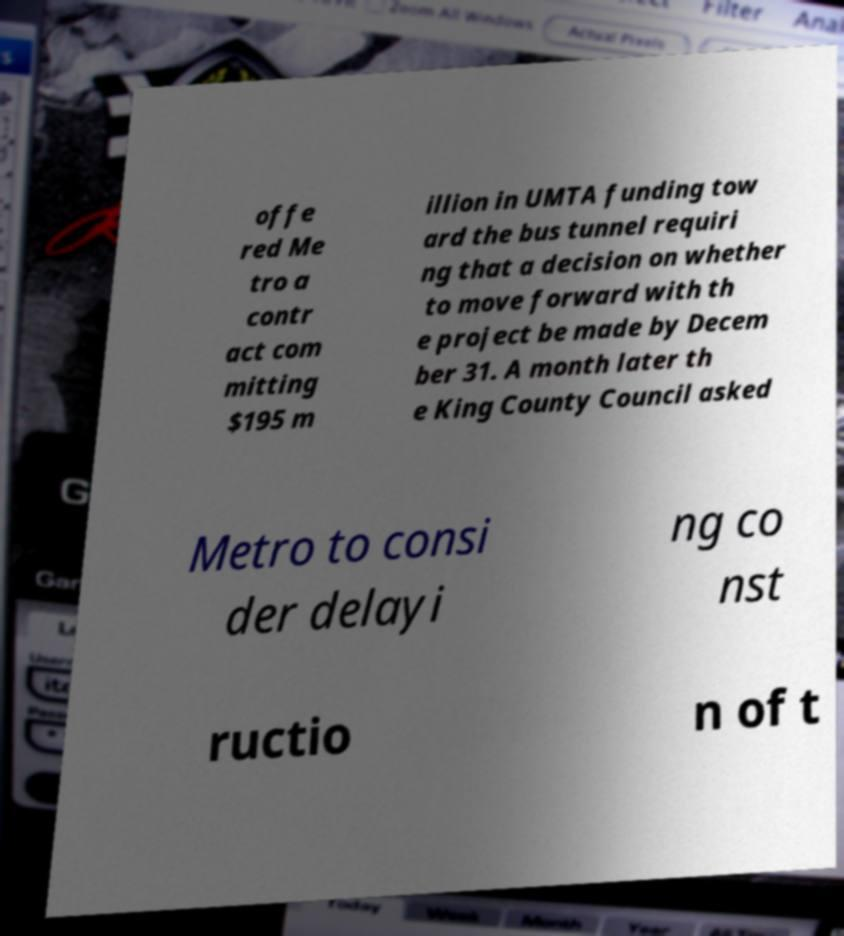There's text embedded in this image that I need extracted. Can you transcribe it verbatim? offe red Me tro a contr act com mitting $195 m illion in UMTA funding tow ard the bus tunnel requiri ng that a decision on whether to move forward with th e project be made by Decem ber 31. A month later th e King County Council asked Metro to consi der delayi ng co nst ructio n of t 